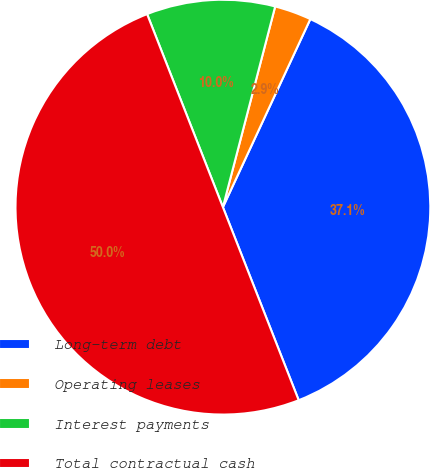Convert chart. <chart><loc_0><loc_0><loc_500><loc_500><pie_chart><fcel>Long-term debt<fcel>Operating leases<fcel>Interest payments<fcel>Total contractual cash<nl><fcel>37.12%<fcel>2.87%<fcel>10.01%<fcel>50.0%<nl></chart> 